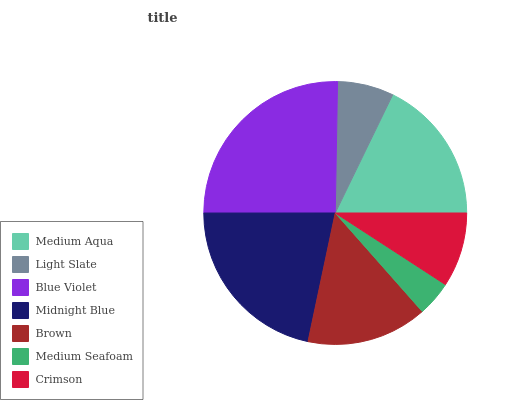Is Medium Seafoam the minimum?
Answer yes or no. Yes. Is Blue Violet the maximum?
Answer yes or no. Yes. Is Light Slate the minimum?
Answer yes or no. No. Is Light Slate the maximum?
Answer yes or no. No. Is Medium Aqua greater than Light Slate?
Answer yes or no. Yes. Is Light Slate less than Medium Aqua?
Answer yes or no. Yes. Is Light Slate greater than Medium Aqua?
Answer yes or no. No. Is Medium Aqua less than Light Slate?
Answer yes or no. No. Is Brown the high median?
Answer yes or no. Yes. Is Brown the low median?
Answer yes or no. Yes. Is Light Slate the high median?
Answer yes or no. No. Is Light Slate the low median?
Answer yes or no. No. 